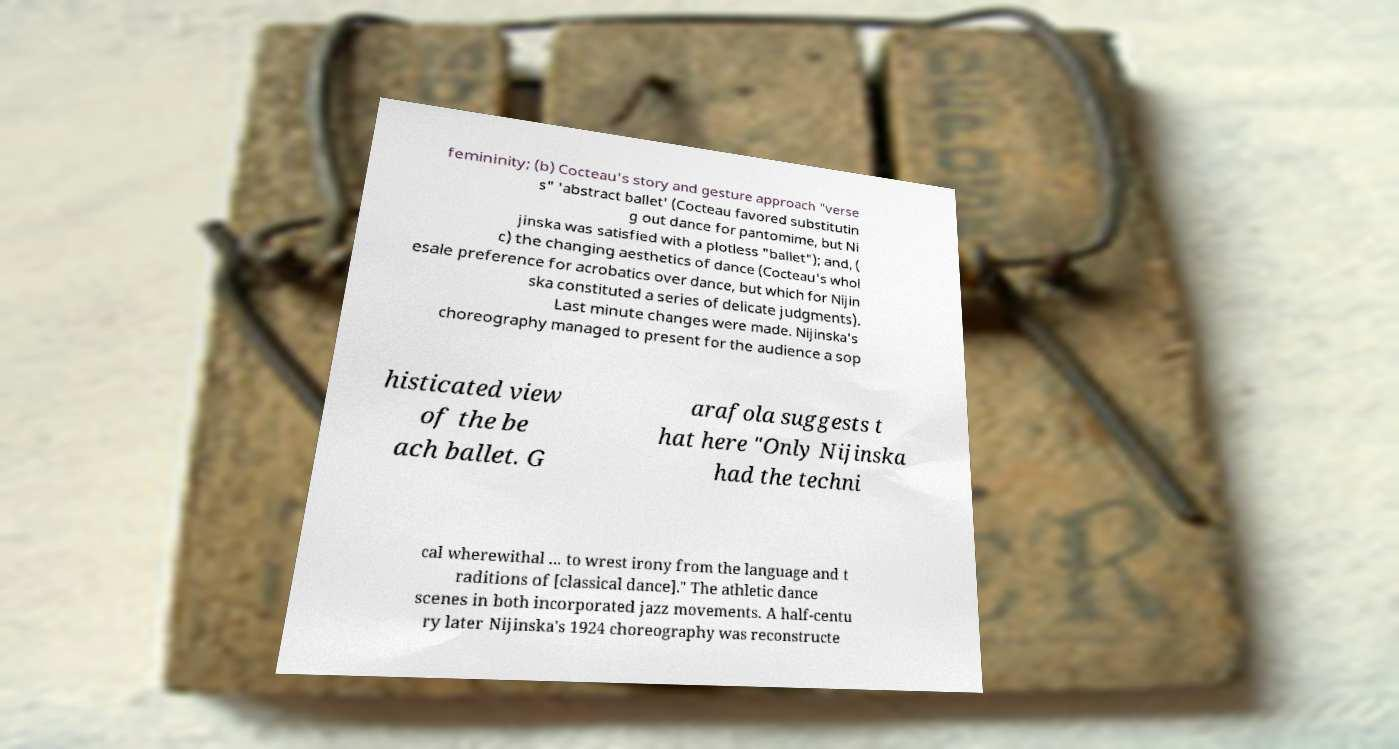Can you accurately transcribe the text from the provided image for me? femininity; (b) Cocteau's story and gesture approach "verse s" 'abstract ballet' (Cocteau favored substitutin g out dance for pantomime, but Ni jinska was satisfied with a plotless "ballet"); and, ( c) the changing aesthetics of dance (Cocteau's whol esale preference for acrobatics over dance, but which for Nijin ska constituted a series of delicate judgments). Last minute changes were made. Nijinska's choreography managed to present for the audience a sop histicated view of the be ach ballet. G arafola suggests t hat here "Only Nijinska had the techni cal wherewithal ... to wrest irony from the language and t raditions of [classical dance]." The athletic dance scenes in both incorporated jazz movements. A half-centu ry later Nijinska's 1924 choreography was reconstructe 